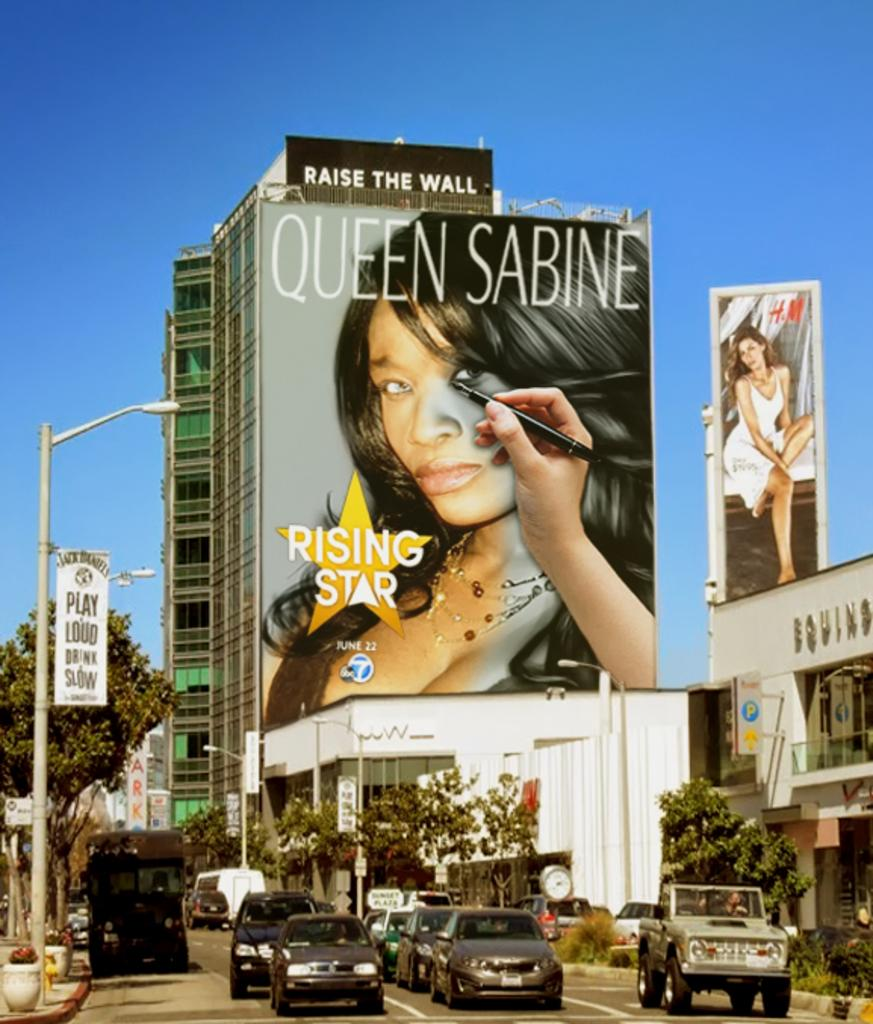What types of vehicles can be seen at the bottom of the image? There are cars at the bottom of the image. What other objects are present at the bottom of the image? Street lights, posters, trees, buildings, and plants are present at the bottom of the image. What is the main feature at the bottom of the image? There is a road at the bottom of the image. What can be seen in the middle of the image? Buildings, posters, sign boards, and the sky are visible in the middle of the image. What type of oatmeal is being served at the amusement park in the image? There is no amusement park or oatmeal present in the image. How many bananas are hanging from the sign boards in the middle of the image? There are no bananas present in the image; sign boards and other objects are visible in the middle of the image. 